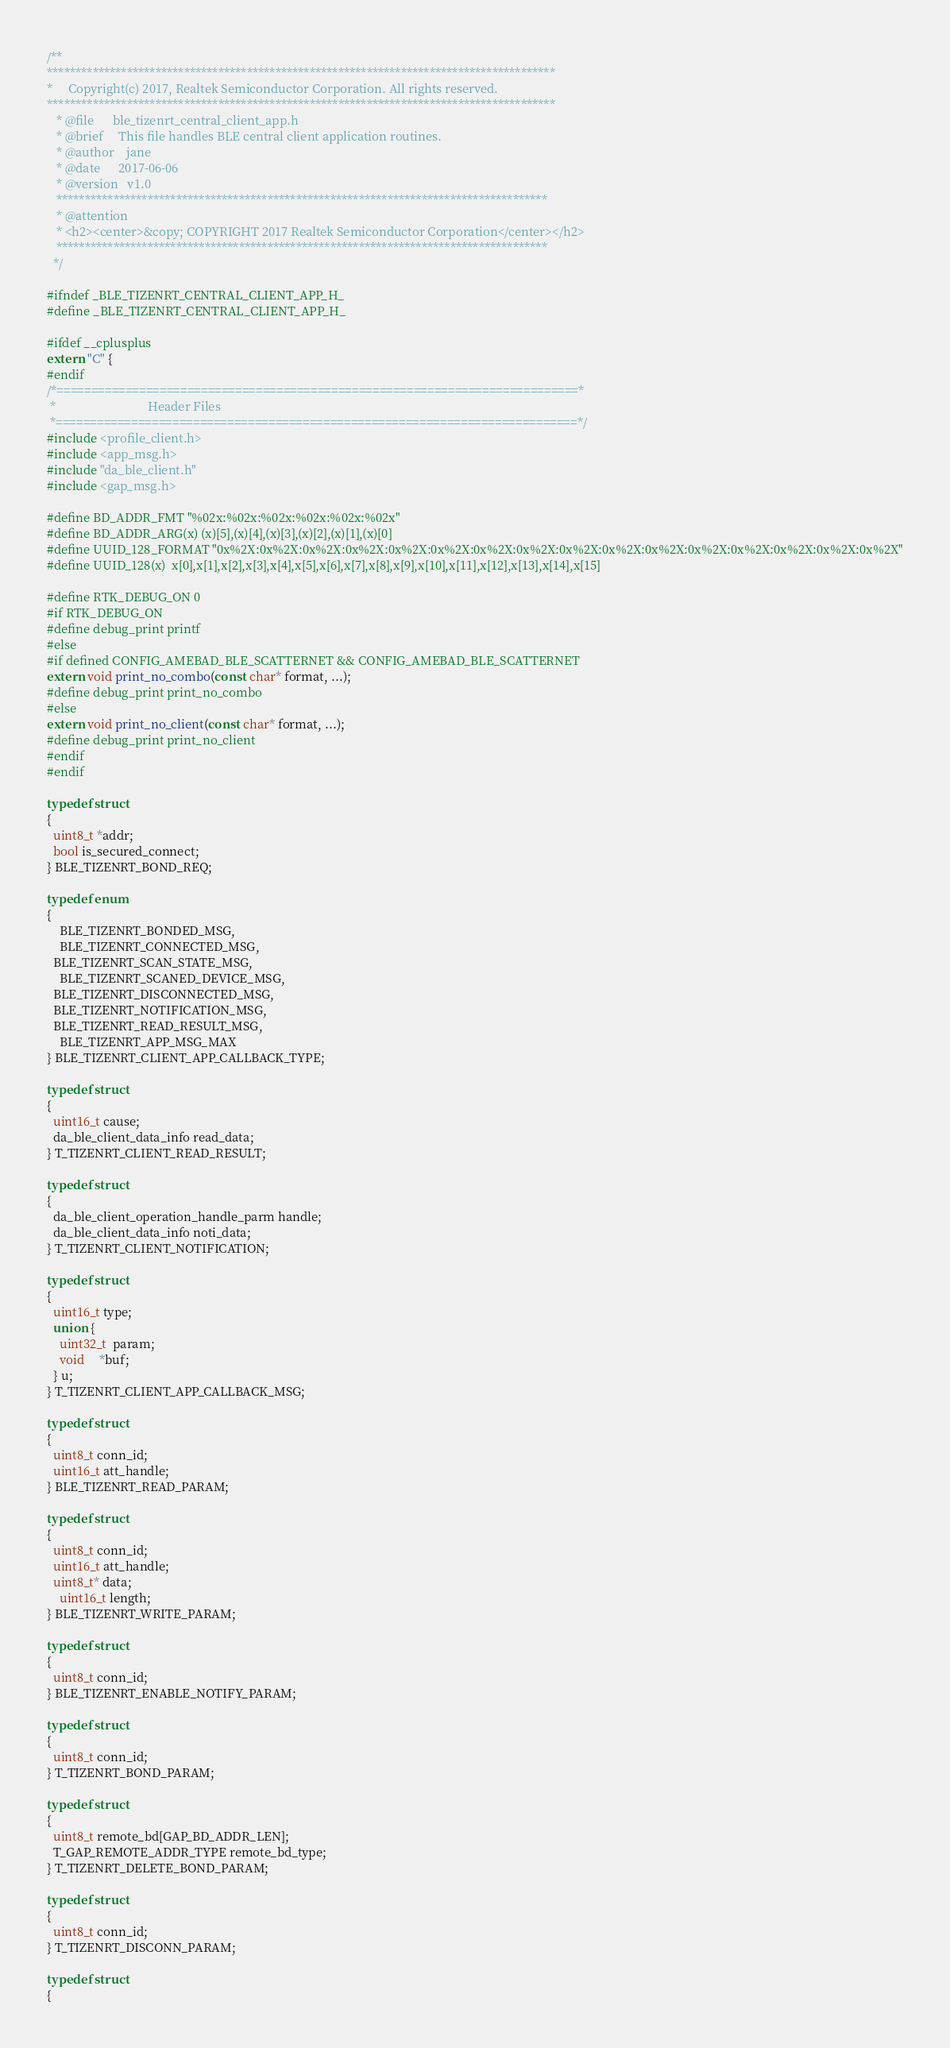<code> <loc_0><loc_0><loc_500><loc_500><_C_>/**
*****************************************************************************************
*     Copyright(c) 2017, Realtek Semiconductor Corporation. All rights reserved.
*****************************************************************************************
   * @file      ble_tizenrt_central_client_app.h
   * @brief     This file handles BLE central client application routines.
   * @author    jane
   * @date      2017-06-06
   * @version   v1.0
   **************************************************************************************
   * @attention
   * <h2><center>&copy; COPYRIGHT 2017 Realtek Semiconductor Corporation</center></h2>
   **************************************************************************************
  */

#ifndef _BLE_TIZENRT_CENTRAL_CLIENT_APP_H_
#define _BLE_TIZENRT_CENTRAL_CLIENT_APP_H_

#ifdef __cplusplus
extern "C" {
#endif
/*============================================================================*
 *                              Header Files
 *============================================================================*/
#include <profile_client.h>
#include <app_msg.h>
#include "da_ble_client.h"
#include <gap_msg.h>

#define BD_ADDR_FMT "%02x:%02x:%02x:%02x:%02x:%02x"
#define BD_ADDR_ARG(x) (x)[5],(x)[4],(x)[3],(x)[2],(x)[1],(x)[0]
#define UUID_128_FORMAT "0x%2X:0x%2X:0x%2X:0x%2X:0x%2X:0x%2X:0x%2X:0x%2X:0x%2X:0x%2X:0x%2X:0x%2X:0x%2X:0x%2X:0x%2X:0x%2X"
#define UUID_128(x)  x[0],x[1],x[2],x[3],x[4],x[5],x[6],x[7],x[8],x[9],x[10],x[11],x[12],x[13],x[14],x[15]

#define RTK_DEBUG_ON 0
#if RTK_DEBUG_ON
#define debug_print printf
#else
#if defined CONFIG_AMEBAD_BLE_SCATTERNET && CONFIG_AMEBAD_BLE_SCATTERNET
extern void print_no_combo(const char* format, ...);
#define debug_print print_no_combo
#else
extern void print_no_client(const char* format, ...);
#define debug_print print_no_client
#endif
#endif

typedef struct
{
  uint8_t *addr;
  bool is_secured_connect;
} BLE_TIZENRT_BOND_REQ;

typedef enum
{
	BLE_TIZENRT_BONDED_MSG,
	BLE_TIZENRT_CONNECTED_MSG,
  BLE_TIZENRT_SCAN_STATE_MSG,
	BLE_TIZENRT_SCANED_DEVICE_MSG,
  BLE_TIZENRT_DISCONNECTED_MSG,
  BLE_TIZENRT_NOTIFICATION_MSG,
  BLE_TIZENRT_READ_RESULT_MSG,
	BLE_TIZENRT_APP_MSG_MAX
} BLE_TIZENRT_CLIENT_APP_CALLBACK_TYPE;

typedef struct
{
  uint16_t cause;
  da_ble_client_data_info read_data;
} T_TIZENRT_CLIENT_READ_RESULT;

typedef struct
{
  da_ble_client_operation_handle_parm handle;
  da_ble_client_data_info noti_data;
} T_TIZENRT_CLIENT_NOTIFICATION;

typedef struct
{
  uint16_t type;
  union {
    uint32_t  param;
    void     *buf;
  } u;
} T_TIZENRT_CLIENT_APP_CALLBACK_MSG;

typedef struct
{
  uint8_t conn_id;
  uint16_t att_handle;
} BLE_TIZENRT_READ_PARAM;

typedef struct
{
  uint8_t conn_id;
  uint16_t att_handle;
  uint8_t* data;
	uint16_t length;
} BLE_TIZENRT_WRITE_PARAM;

typedef struct
{
  uint8_t conn_id;
} BLE_TIZENRT_ENABLE_NOTIFY_PARAM;

typedef struct
{
  uint8_t conn_id;
} T_TIZENRT_BOND_PARAM;

typedef struct
{
  uint8_t remote_bd[GAP_BD_ADDR_LEN];
  T_GAP_REMOTE_ADDR_TYPE remote_bd_type;
} T_TIZENRT_DELETE_BOND_PARAM;

typedef struct
{
  uint8_t conn_id;
} T_TIZENRT_DISCONN_PARAM;

typedef struct
{</code> 